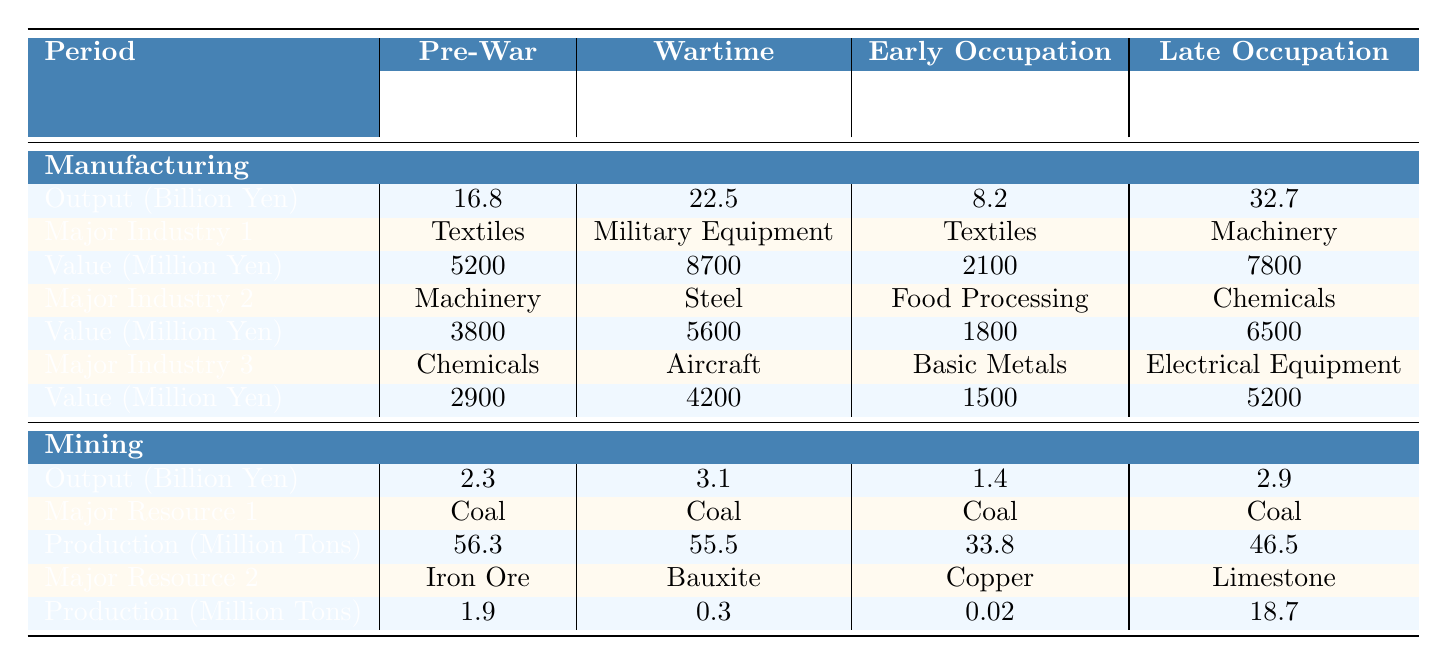What was the manufacturing output in Japan during the Wartime period? The table indicates that the manufacturing output during the Wartime period (1942-1945) was 22.5 billion yen.
Answer: 22.5 billion yen Which major industry had the highest production value in the Late Occupation and Recovery period? Referring to the table, in the Late Occupation and Recovery period (1950-1955), the major industry with the highest production value was Machinery at 7800 million yen.
Answer: Machinery What was the total production value of major industries in the Pre-War manufacturing sector? To find this, we sum the production values of Textiles (5200 million yen), Machinery (3800 million yen), and Chemicals (2900 million yen), resulting in 5200 + 3800 + 2900 = 11900 million yen.
Answer: 11900 million yen Was coal the primary resource mined during the Early Occupation period? Yes, the table shows that coal was the only major resource listed for mining during the Early Occupation period (1946-1949).
Answer: Yes How did the manufacturing output change from the Early Occupation to the Late Occupation period? The manufacturing output during the Early Occupation (8.2 billion yen) increased to 32.7 billion yen during the Late Occupation and Recovery period, leading to a change of 32.7 - 8.2 = 24.5 billion yen increase.
Answer: 24.5 billion yen increase What was the production value of Military Equipment compared to Electrical Equipment? The production value of Military Equipment during the Wartime was 8700 million yen, while for Electrical Equipment in the Late Occupation and Recovery period it was 5200 million yen. Comparing these, Military Equipment had a higher value by 8700 - 5200 = 3500 million yen.
Answer: 3500 million yen higher In which sector did mining see the least output, and what was that output? Referring to the table, the mining output during the Early Occupation period was the least at 1.4 billion yen.
Answer: 1.4 billion yen What is the difference in production value of Chemicals between the Pre-War and the Late Occupation and Recovery periods? The production value of Chemicals in the Pre-War period was 2900 million yen, and in the Late Occupation and Recovery period, it was 6500 million yen. The difference is 6500 - 2900 = 3600 million yen.
Answer: 3600 million yen Did the overall industrial output increase or decrease from the Wartime to the Early Occupation period? The table shows a decrease from 22.5 billion yen in the Wartime period to 8.2 billion yen in the Early Occupation period, indicating a decline.
Answer: Decrease Which period had the highest coal production, and what was the amount produced? According to the table, coal production was highest in the Pre-War period with 56.3 million tons.
Answer: 56.3 million tons 